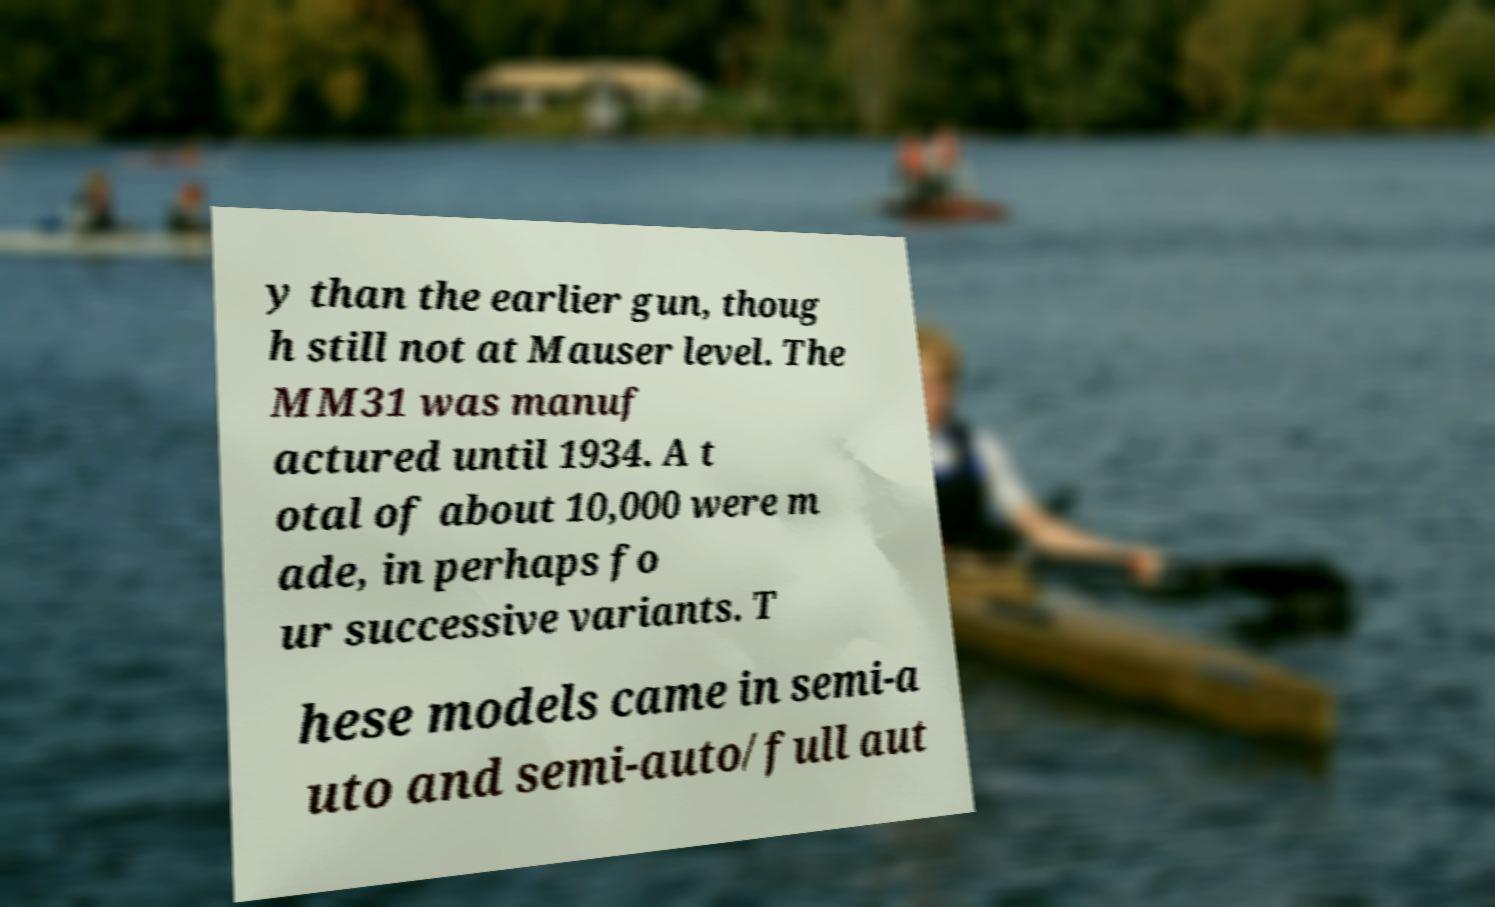Could you assist in decoding the text presented in this image and type it out clearly? y than the earlier gun, thoug h still not at Mauser level. The MM31 was manuf actured until 1934. A t otal of about 10,000 were m ade, in perhaps fo ur successive variants. T hese models came in semi-a uto and semi-auto/full aut 